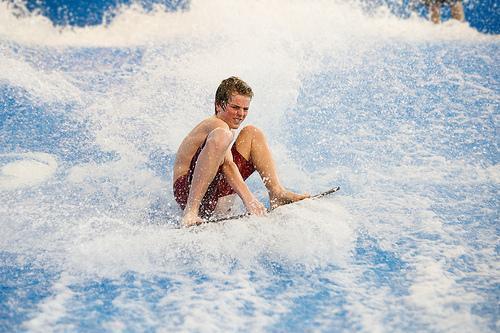How many people in the photo?
Give a very brief answer. 1. How many surfboards are seen?
Give a very brief answer. 1. 